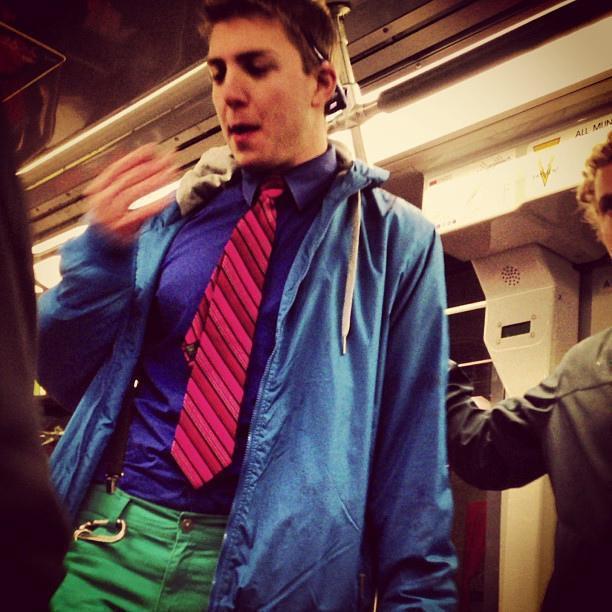What is clipped to the green pants?
Choose the correct response, then elucidate: 'Answer: answer
Rationale: rationale.'
Options: Carabiner, paper clip, bobby pin, bread clip. Answer: carabiner.
Rationale: The object is round and elongated, and had a moveable latch section. carabiners are not a strange thing to find attached to a belt loop, they can be used to hold keys or other common carry items. 